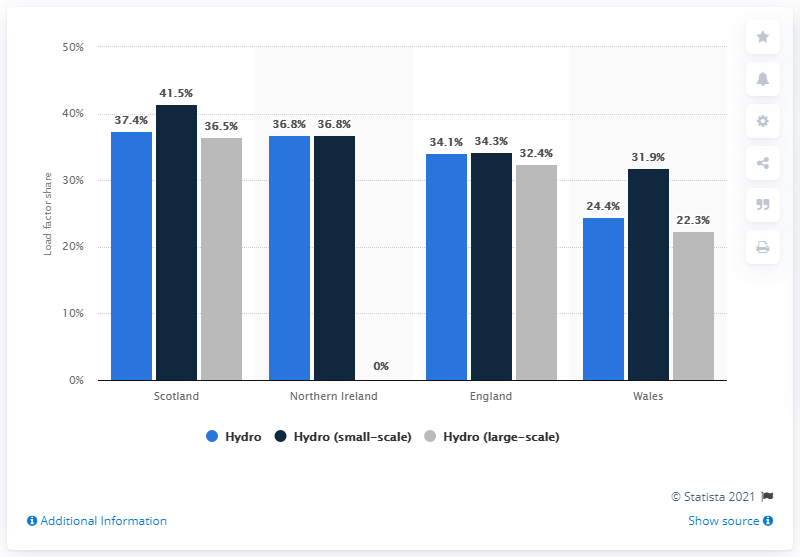Indicate a few pertinent items in this graphic. The load factor of hydropower in Wales was 24.4%. Scotland's hydropower load factor was 37.4%. Scotland has the highest hydropower load factor among the countries in the UK. The lowest possible percentage value of a gray bar is 0%. This applies to any range of values that is defined as 0.., which represents a range of 0% to 100%. In how many countries is the product of the light blue bar and the gray bar equal to zero? 